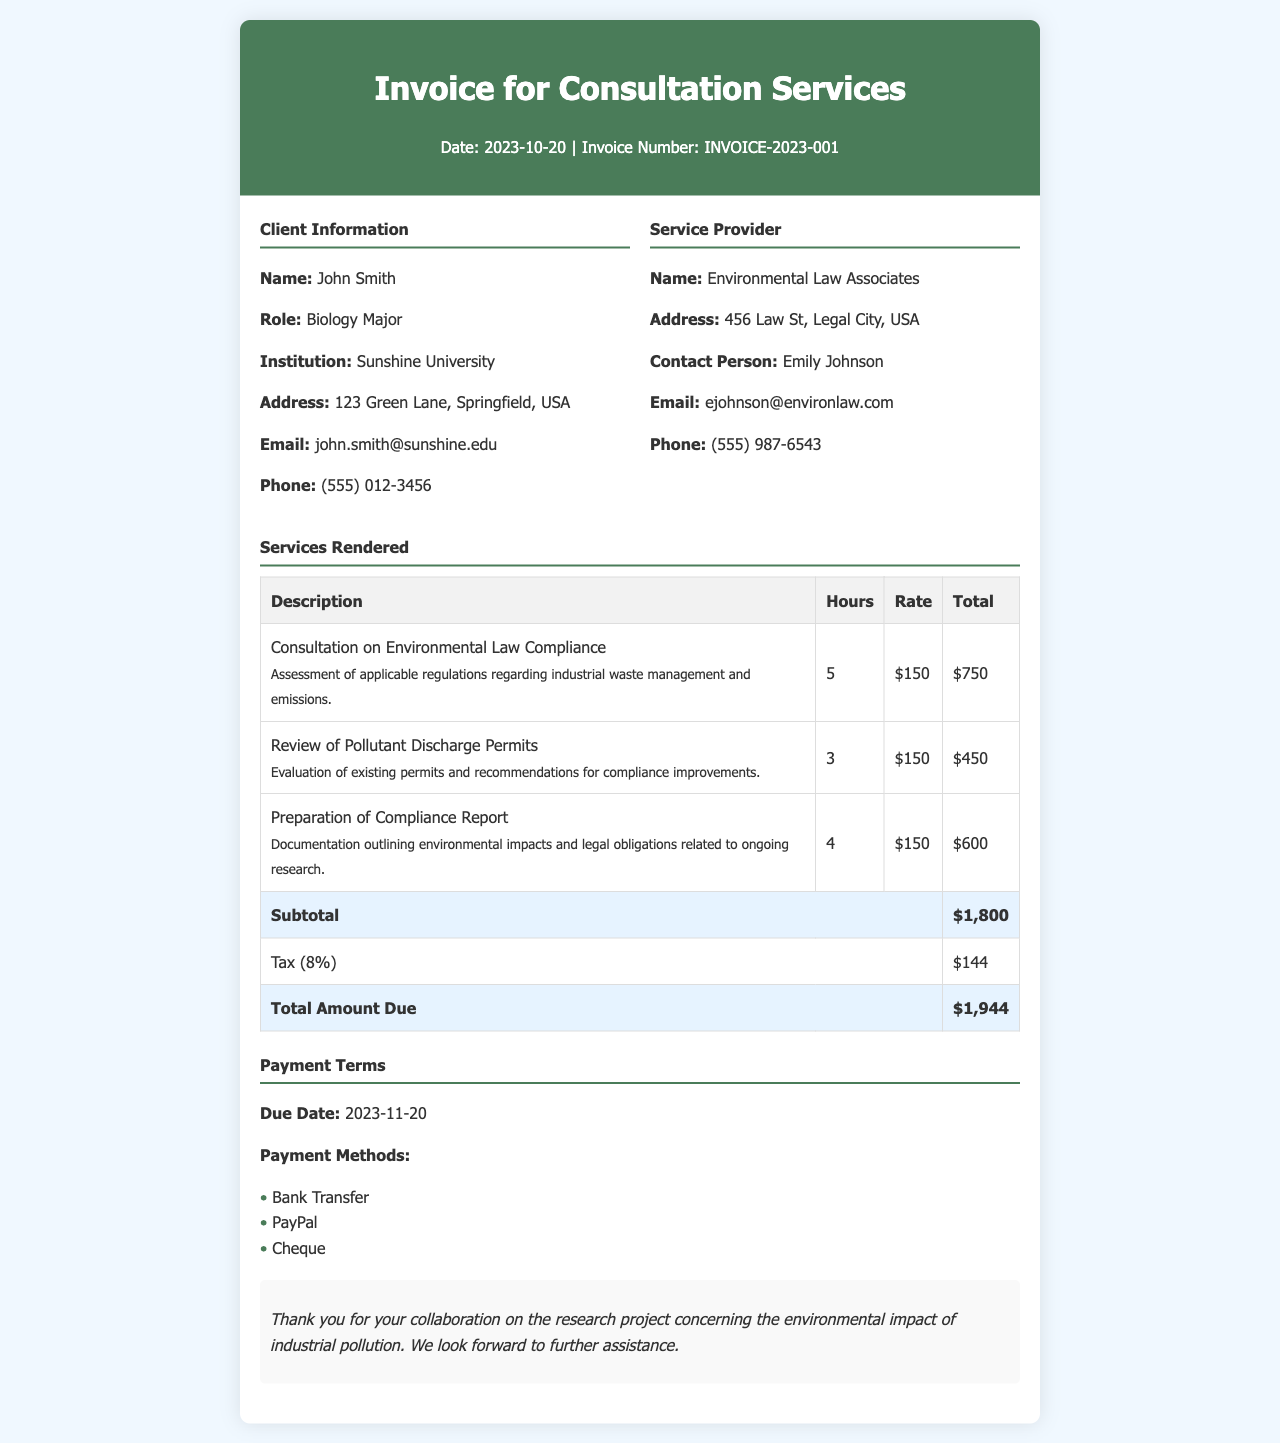what is the date of the invoice? The invoice date is clearly stated in the header section as the date when the invoice is issued.
Answer: 2023-10-20 what is the invoice number? The invoice number uniquely identifies this particular invoice, and it is mentioned in the header section.
Answer: INVOICE-2023-001 who is the client? The client information section identifies the person who received the services rendered as well as their details.
Answer: John Smith what is the total amount due? The total amount due is calculated in the services rendered section, summarizing all charges.
Answer: $1,944 how many hours were spent on the consultation for environmental law compliance? This information is found in the services rendered table, under the hours column for that specific service.
Answer: 5 who is the contact person for the service provider? The contact person is specified in the service provider section, indicating who can be reached for this service.
Answer: Emily Johnson what payment methods are available? The available payment methods are listed in the payment terms section of the document.
Answer: Bank Transfer, PayPal, Cheque what is the due date for payment? The due date for payment is explicitly stated in the payment terms section, indicating when the payment must be made.
Answer: 2023-11-20 what was the subtotal before tax? The subtotal is provided in the services rendered section before applying any taxes.
Answer: $1,800 